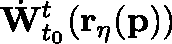Convert formula to latex. <formula><loc_0><loc_0><loc_500><loc_500>\dot { W } _ { t _ { 0 } } ^ { t } ( r _ { \eta } ( p ) )</formula> 